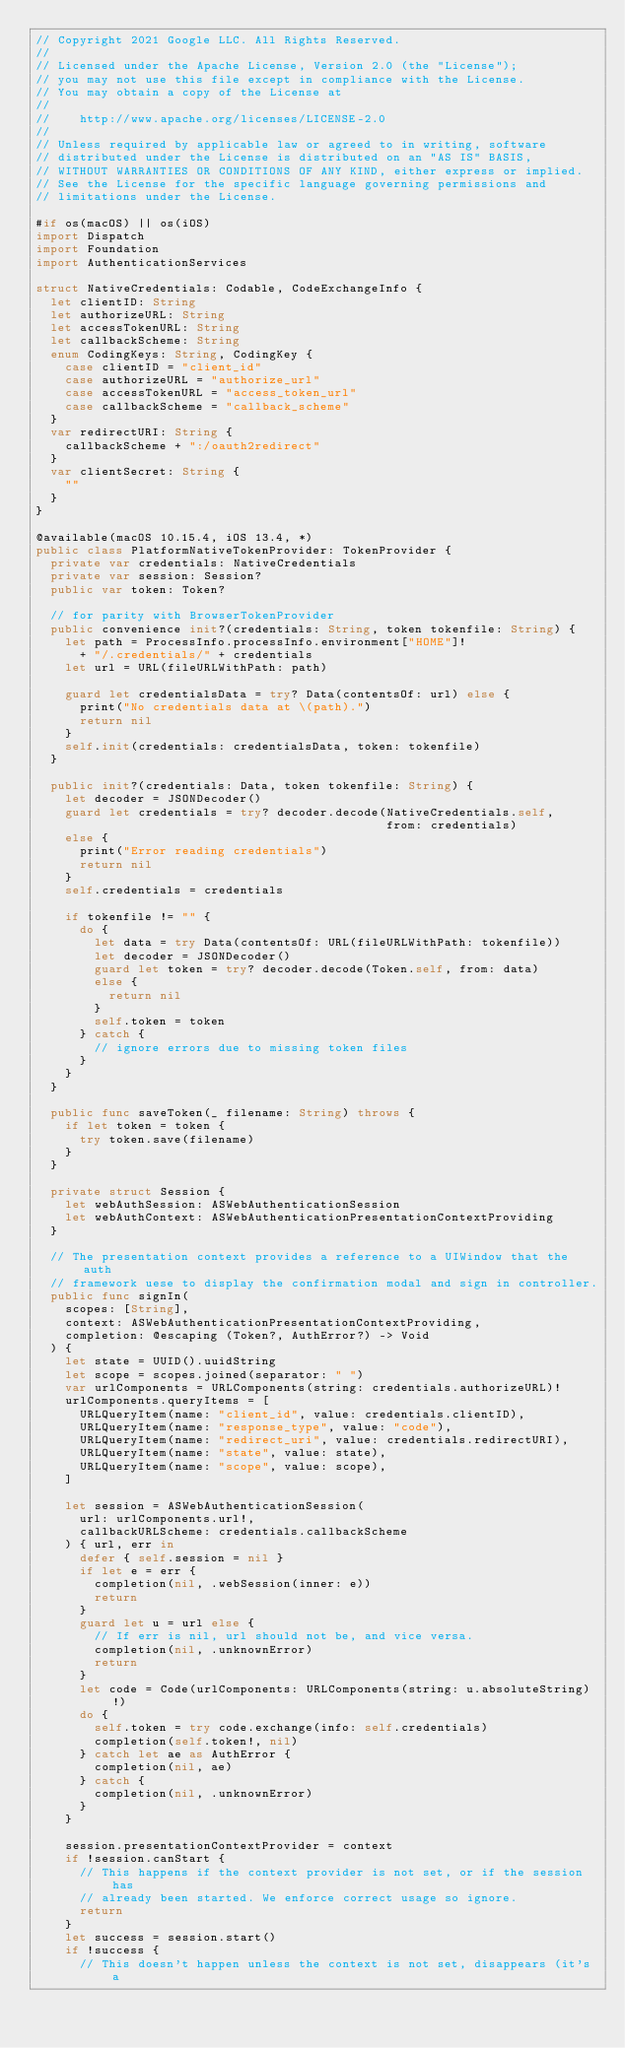<code> <loc_0><loc_0><loc_500><loc_500><_Swift_>// Copyright 2021 Google LLC. All Rights Reserved.
//
// Licensed under the Apache License, Version 2.0 (the "License");
// you may not use this file except in compliance with the License.
// You may obtain a copy of the License at
//
//    http://www.apache.org/licenses/LICENSE-2.0
//
// Unless required by applicable law or agreed to in writing, software
// distributed under the License is distributed on an "AS IS" BASIS,
// WITHOUT WARRANTIES OR CONDITIONS OF ANY KIND, either express or implied.
// See the License for the specific language governing permissions and
// limitations under the License.

#if os(macOS) || os(iOS)
import Dispatch
import Foundation
import AuthenticationServices

struct NativeCredentials: Codable, CodeExchangeInfo {
  let clientID: String
  let authorizeURL: String
  let accessTokenURL: String
  let callbackScheme: String
  enum CodingKeys: String, CodingKey {
    case clientID = "client_id"
    case authorizeURL = "authorize_url"
    case accessTokenURL = "access_token_url"
    case callbackScheme = "callback_scheme"
  }
  var redirectURI: String {
    callbackScheme + ":/oauth2redirect"
  }
  var clientSecret: String {
    ""
  }
}

@available(macOS 10.15.4, iOS 13.4, *)
public class PlatformNativeTokenProvider: TokenProvider {
  private var credentials: NativeCredentials
  private var session: Session?
  public var token: Token?

  // for parity with BrowserTokenProvider
  public convenience init?(credentials: String, token tokenfile: String) {
    let path = ProcessInfo.processInfo.environment["HOME"]!
      + "/.credentials/" + credentials
    let url = URL(fileURLWithPath: path)

    guard let credentialsData = try? Data(contentsOf: url) else {
      print("No credentials data at \(path).")
      return nil
    }
    self.init(credentials: credentialsData, token: tokenfile)
  }

  public init?(credentials: Data, token tokenfile: String) {
    let decoder = JSONDecoder()
    guard let credentials = try? decoder.decode(NativeCredentials.self,
                                                from: credentials)
    else {
      print("Error reading credentials")
      return nil
    }
    self.credentials = credentials

    if tokenfile != "" {
      do {
        let data = try Data(contentsOf: URL(fileURLWithPath: tokenfile))
        let decoder = JSONDecoder()
        guard let token = try? decoder.decode(Token.self, from: data)
        else {
          return nil
        }
        self.token = token
      } catch {
        // ignore errors due to missing token files
      }
    }
  }

  public func saveToken(_ filename: String) throws {
    if let token = token {
      try token.save(filename)
    }
  }

  private struct Session {
    let webAuthSession: ASWebAuthenticationSession
    let webAuthContext: ASWebAuthenticationPresentationContextProviding
  }

  // The presentation context provides a reference to a UIWindow that the auth
  // framework uese to display the confirmation modal and sign in controller.
  public func signIn(
    scopes: [String],
    context: ASWebAuthenticationPresentationContextProviding,
    completion: @escaping (Token?, AuthError?) -> Void
  ) {
    let state = UUID().uuidString
    let scope = scopes.joined(separator: " ")
    var urlComponents = URLComponents(string: credentials.authorizeURL)!
    urlComponents.queryItems = [
      URLQueryItem(name: "client_id", value: credentials.clientID),
      URLQueryItem(name: "response_type", value: "code"),
      URLQueryItem(name: "redirect_uri", value: credentials.redirectURI),
      URLQueryItem(name: "state", value: state),
      URLQueryItem(name: "scope", value: scope),
    ]

    let session = ASWebAuthenticationSession(
      url: urlComponents.url!,
      callbackURLScheme: credentials.callbackScheme
    ) { url, err in
      defer { self.session = nil }
      if let e = err {
        completion(nil, .webSession(inner: e))
        return
      }
      guard let u = url else {
        // If err is nil, url should not be, and vice versa.
        completion(nil, .unknownError)
        return
      }
      let code = Code(urlComponents: URLComponents(string: u.absoluteString)!)
      do {
        self.token = try code.exchange(info: self.credentials)
        completion(self.token!, nil)
      } catch let ae as AuthError {
        completion(nil, ae)
      } catch {
        completion(nil, .unknownError)
      }
    }

    session.presentationContextProvider = context
    if !session.canStart {
      // This happens if the context provider is not set, or if the session has
      // already been started. We enforce correct usage so ignore.
      return
    }
    let success = session.start()
    if !success {
      // This doesn't happen unless the context is not set, disappears (it's a</code> 